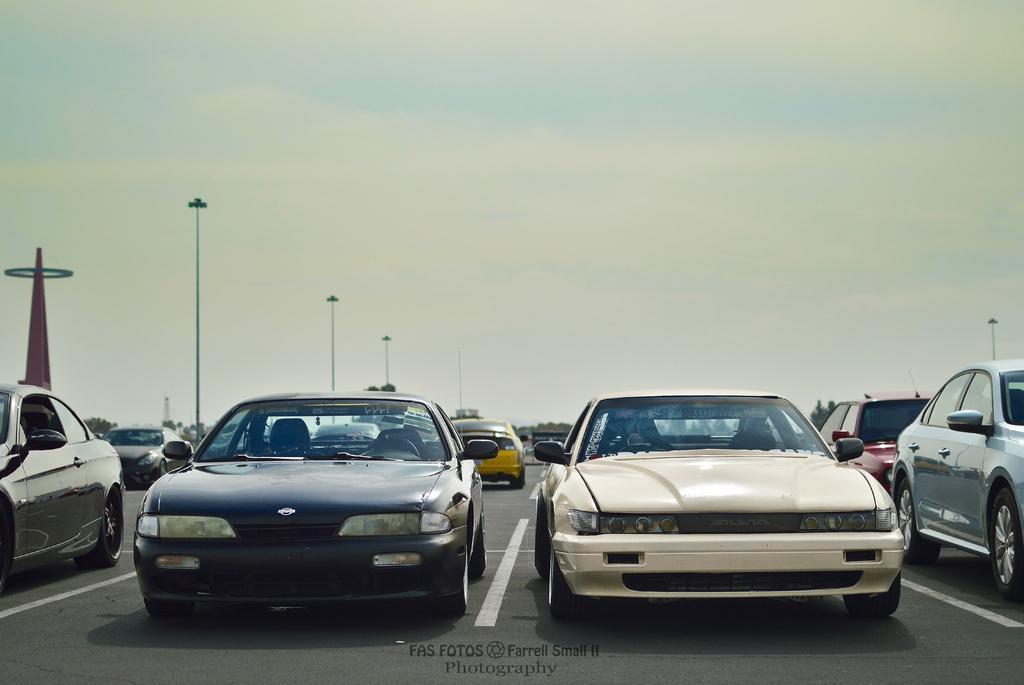In one or two sentences, can you explain what this image depicts? In this picture we can see cars on the road, tower, street light poles, trees and in the background we can see the sky with clouds. 